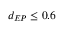Convert formula to latex. <formula><loc_0><loc_0><loc_500><loc_500>d _ { E P } \leq 0 . 6</formula> 